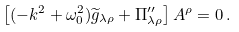<formula> <loc_0><loc_0><loc_500><loc_500>\left [ ( - k ^ { 2 } + \omega _ { 0 } ^ { 2 } ) \widetilde { g } _ { \lambda \rho } + \Pi _ { \lambda \rho } ^ { \prime \prime } \right ] A ^ { \rho } = 0 \, .</formula> 